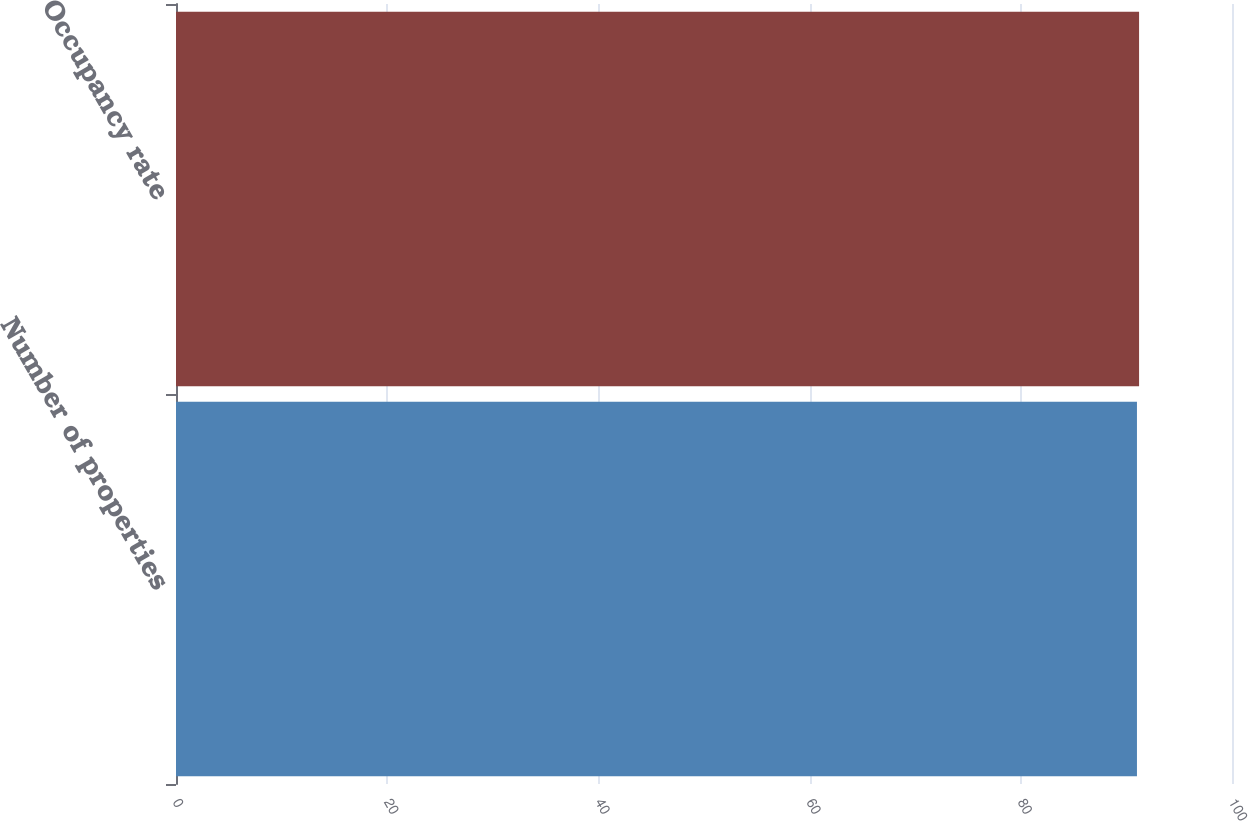Convert chart. <chart><loc_0><loc_0><loc_500><loc_500><bar_chart><fcel>Number of properties<fcel>Occupancy rate<nl><fcel>91<fcel>91.2<nl></chart> 